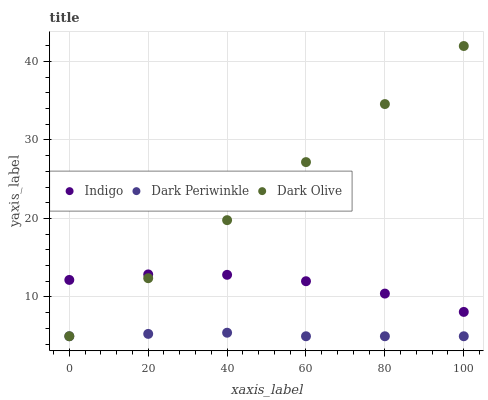Does Dark Periwinkle have the minimum area under the curve?
Answer yes or no. Yes. Does Dark Olive have the maximum area under the curve?
Answer yes or no. Yes. Does Indigo have the minimum area under the curve?
Answer yes or no. No. Does Indigo have the maximum area under the curve?
Answer yes or no. No. Is Dark Olive the smoothest?
Answer yes or no. Yes. Is Indigo the roughest?
Answer yes or no. Yes. Is Dark Periwinkle the smoothest?
Answer yes or no. No. Is Dark Periwinkle the roughest?
Answer yes or no. No. Does Dark Olive have the lowest value?
Answer yes or no. Yes. Does Indigo have the lowest value?
Answer yes or no. No. Does Dark Olive have the highest value?
Answer yes or no. Yes. Does Indigo have the highest value?
Answer yes or no. No. Is Dark Periwinkle less than Indigo?
Answer yes or no. Yes. Is Indigo greater than Dark Periwinkle?
Answer yes or no. Yes. Does Dark Olive intersect Indigo?
Answer yes or no. Yes. Is Dark Olive less than Indigo?
Answer yes or no. No. Is Dark Olive greater than Indigo?
Answer yes or no. No. Does Dark Periwinkle intersect Indigo?
Answer yes or no. No. 